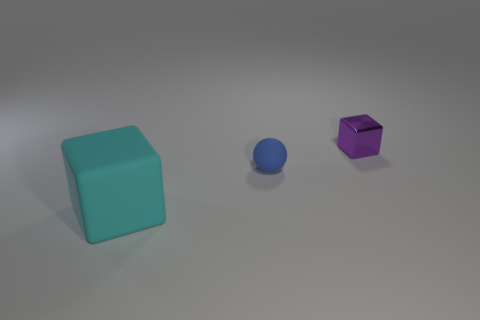What is the material of the ball that is the same size as the purple block?
Your answer should be very brief. Rubber. How many other things are made of the same material as the tiny block?
Offer a very short reply. 0. Are there the same number of objects on the right side of the tiny sphere and tiny purple metal cubes on the right side of the large matte cube?
Your response must be concise. Yes. How many red objects are either rubber cubes or tiny balls?
Make the answer very short. 0. Do the small matte thing and the thing that is left of the blue matte ball have the same color?
Ensure brevity in your answer.  No. What number of other things are there of the same color as the large thing?
Your answer should be compact. 0. Is the number of cyan objects less than the number of big yellow things?
Keep it short and to the point. No. There is a cube that is behind the rubber object that is in front of the blue ball; how many blocks are in front of it?
Make the answer very short. 1. There is a rubber object in front of the sphere; how big is it?
Provide a succinct answer. Large. Do the small thing that is in front of the tiny purple block and the purple shiny object have the same shape?
Provide a succinct answer. No. 